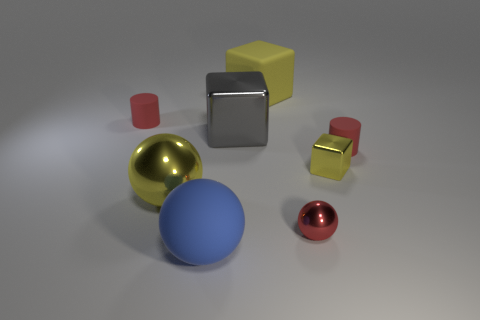There is a big object that is the same color as the large metal ball; what is its material? The material of the large object that matches the color of the metal ball appears to be a plastic or similar synthetic material. This assessment is based on the object's matte surface and lack of reflections which differ from the metallic sheen of the ball. 